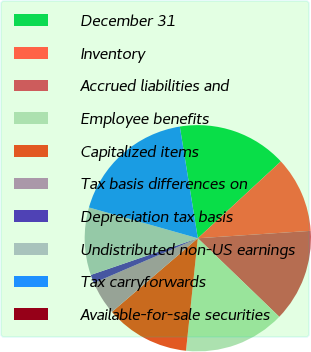Convert chart. <chart><loc_0><loc_0><loc_500><loc_500><pie_chart><fcel>December 31<fcel>Inventory<fcel>Accrued liabilities and<fcel>Employee benefits<fcel>Capitalized items<fcel>Tax basis differences on<fcel>Depreciation tax basis<fcel>Undistributed non-US earnings<fcel>Tax carryforwards<fcel>Available-for-sale securities<nl><fcel>15.66%<fcel>10.84%<fcel>13.25%<fcel>14.46%<fcel>12.05%<fcel>4.82%<fcel>1.21%<fcel>9.64%<fcel>18.07%<fcel>0.0%<nl></chart> 